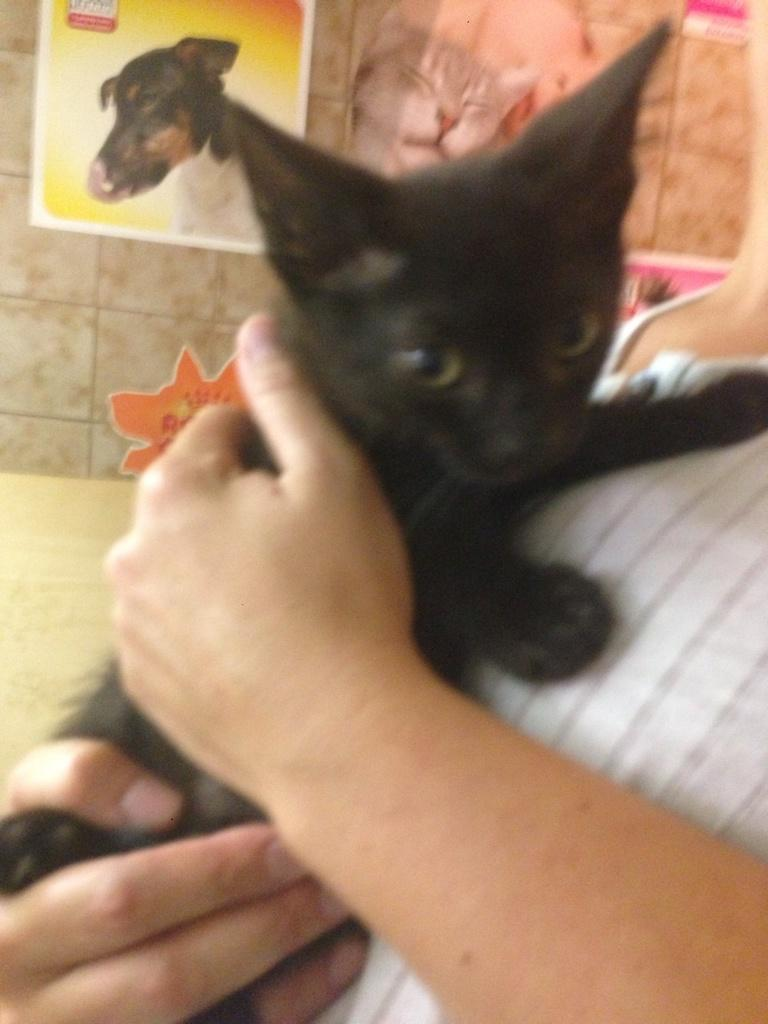Who or what is the main subject in the image? There is a person in the image. What is the person holding in the image? The person is holding a cat. What can be seen in the background of the image? There are posts on the wall in the background of the image. What type of feast is being prepared in the image? There is no indication of a feast or any food preparation in the image. 